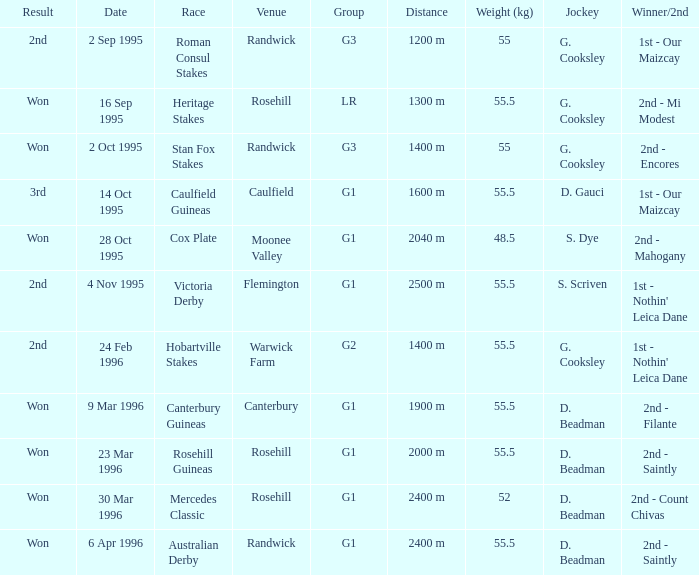At what place did the stan fox stakes take place? Randwick. 